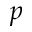<formula> <loc_0><loc_0><loc_500><loc_500>p</formula> 